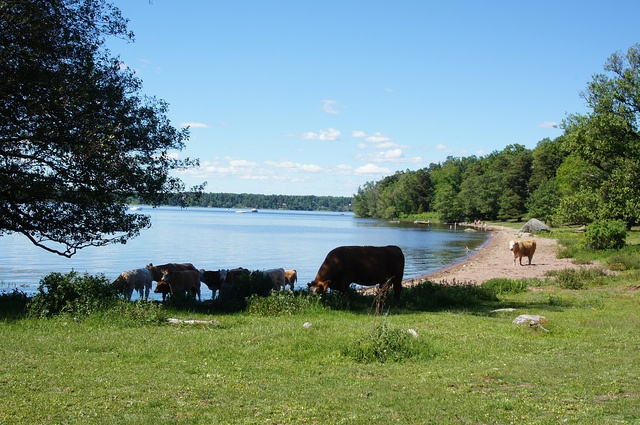Describe the objects in this image and their specific colors. I can see cow in black, maroon, and gray tones, cow in black, navy, gray, and blue tones, cow in black, gray, and maroon tones, cow in black, navy, blue, and lightblue tones, and cow in black, maroon, and gray tones in this image. 